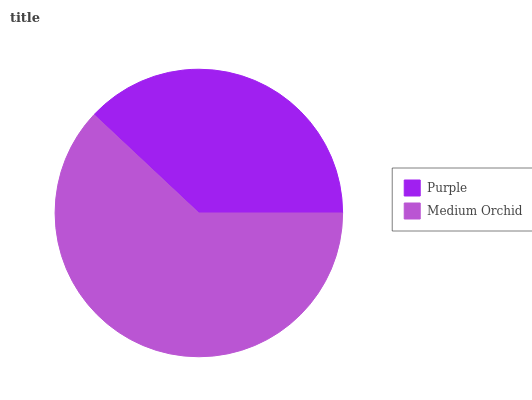Is Purple the minimum?
Answer yes or no. Yes. Is Medium Orchid the maximum?
Answer yes or no. Yes. Is Medium Orchid the minimum?
Answer yes or no. No. Is Medium Orchid greater than Purple?
Answer yes or no. Yes. Is Purple less than Medium Orchid?
Answer yes or no. Yes. Is Purple greater than Medium Orchid?
Answer yes or no. No. Is Medium Orchid less than Purple?
Answer yes or no. No. Is Medium Orchid the high median?
Answer yes or no. Yes. Is Purple the low median?
Answer yes or no. Yes. Is Purple the high median?
Answer yes or no. No. Is Medium Orchid the low median?
Answer yes or no. No. 